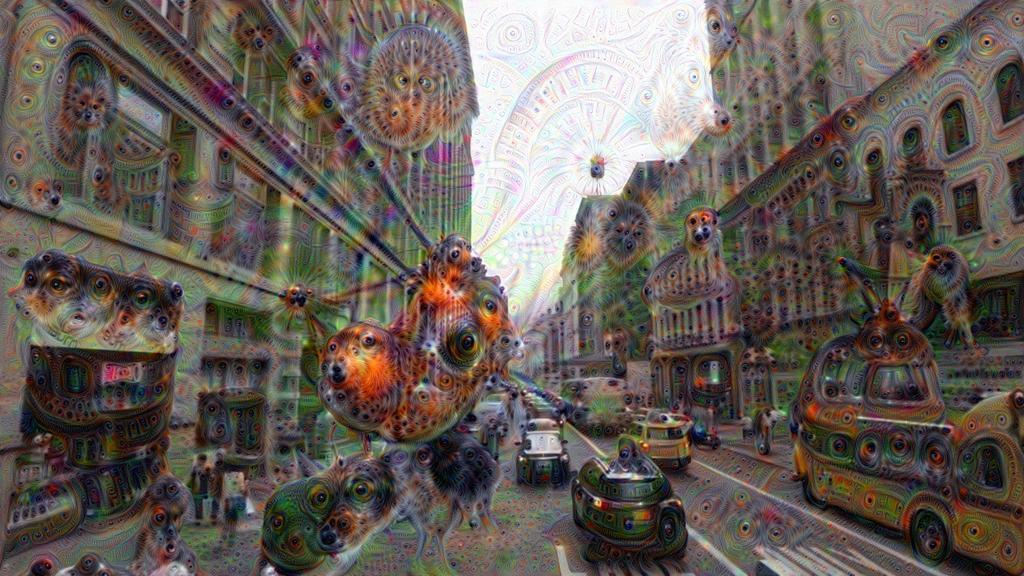What can be observed about the image in terms of editing? The image is edited. What is present on the road in the image? There are vehicles on the road. Where are people located in the image? People can be seen on the left and right sides of the road. What type of structures are visible on both sides of the road? There are buildings on the left and right sides of the road. What is visible at the top of the image? The sky is visible at the top of the image. What type of liquid can be seen flowing from the crate on the right side of the road? There is no crate or liquid present in the image; it features vehicles, people, and buildings on both sides of the road. How many turkeys are visible in the image? There are no turkeys present in the image. 